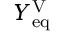<formula> <loc_0><loc_0><loc_500><loc_500>Y _ { e q } ^ { V }</formula> 